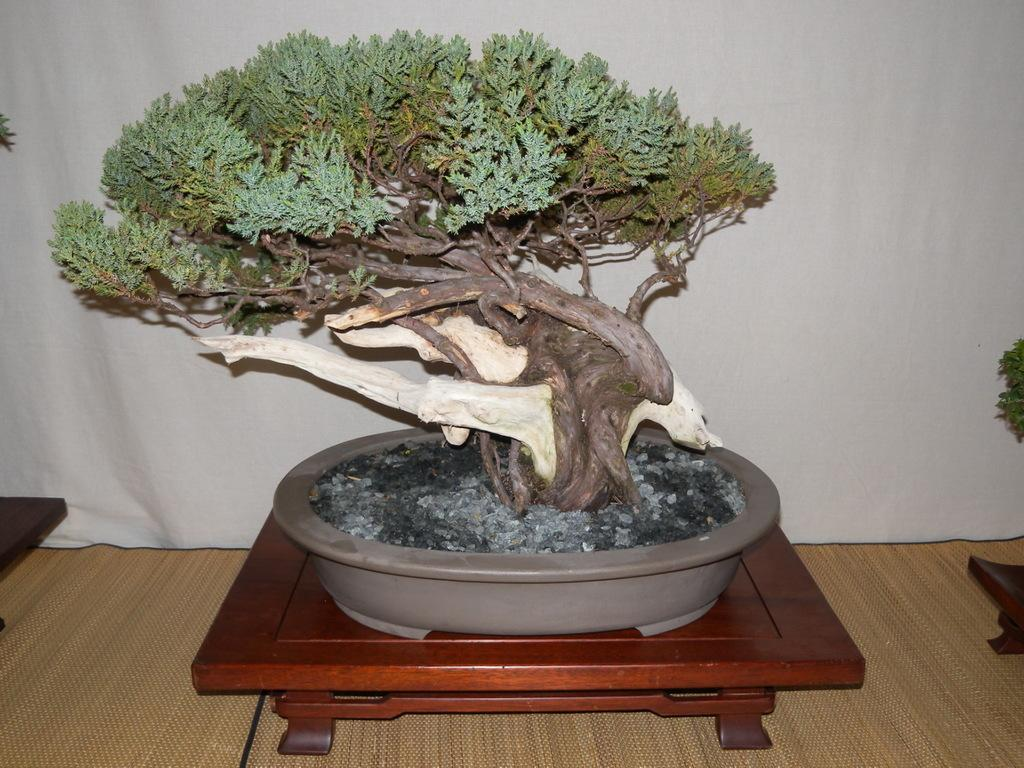What type of objects are in the pots in the image? There are plants in pots in the image. What can be seen on the tables in the image? There are spots on the tables in the image. What is located at the bottom of the image? There are mats at the bottom of the image. What is present at the back of the image? There is a curtain at the back of the image. What type of fruit is displayed on the page in the image? There is no page or fruit present in the image. 